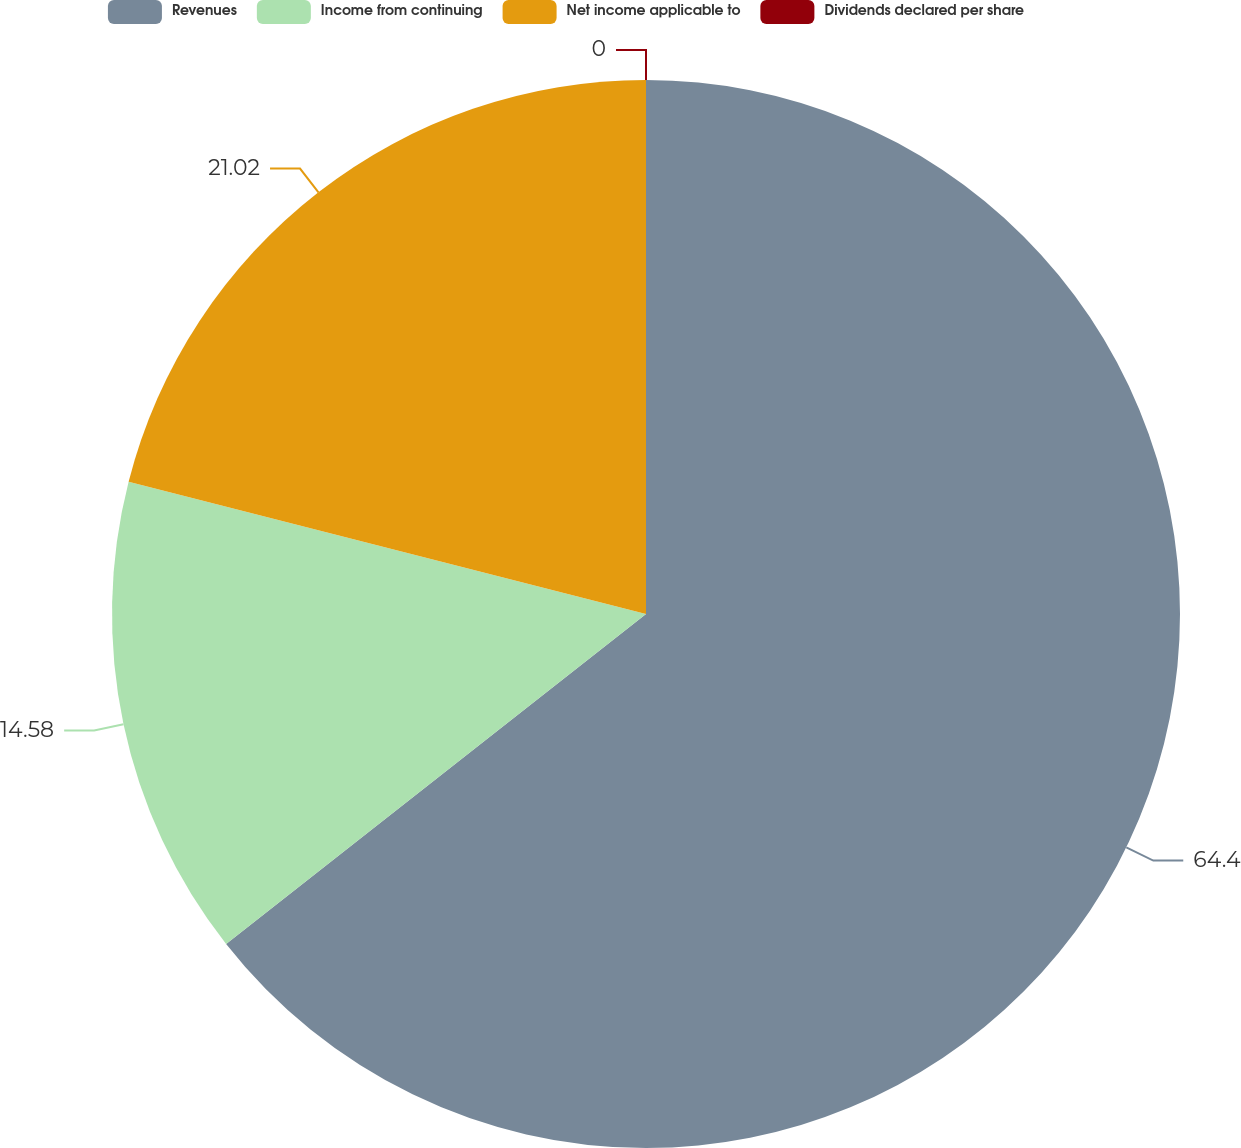Convert chart to OTSL. <chart><loc_0><loc_0><loc_500><loc_500><pie_chart><fcel>Revenues<fcel>Income from continuing<fcel>Net income applicable to<fcel>Dividends declared per share<nl><fcel>64.4%<fcel>14.58%<fcel>21.02%<fcel>0.0%<nl></chart> 